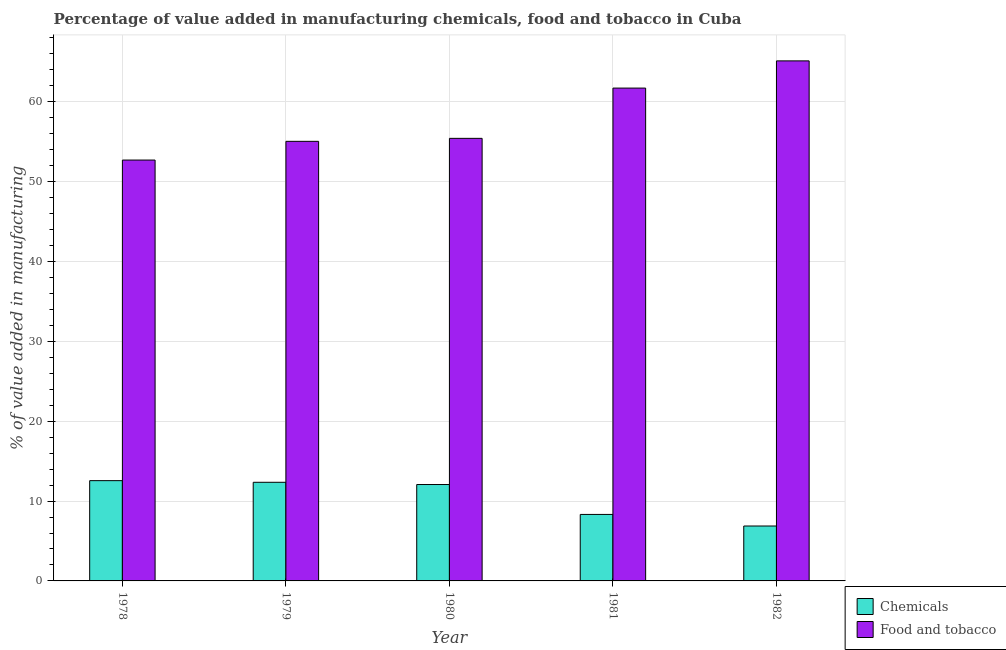How many groups of bars are there?
Keep it short and to the point. 5. Are the number of bars on each tick of the X-axis equal?
Your response must be concise. Yes. In how many cases, is the number of bars for a given year not equal to the number of legend labels?
Make the answer very short. 0. What is the value added by manufacturing food and tobacco in 1979?
Ensure brevity in your answer.  55.05. Across all years, what is the maximum value added by  manufacturing chemicals?
Give a very brief answer. 12.56. Across all years, what is the minimum value added by manufacturing food and tobacco?
Make the answer very short. 52.71. In which year was the value added by  manufacturing chemicals maximum?
Offer a terse response. 1978. In which year was the value added by  manufacturing chemicals minimum?
Give a very brief answer. 1982. What is the total value added by manufacturing food and tobacco in the graph?
Make the answer very short. 290.03. What is the difference between the value added by  manufacturing chemicals in 1980 and that in 1981?
Provide a succinct answer. 3.75. What is the difference between the value added by manufacturing food and tobacco in 1982 and the value added by  manufacturing chemicals in 1980?
Ensure brevity in your answer.  9.7. What is the average value added by manufacturing food and tobacco per year?
Provide a short and direct response. 58.01. In how many years, is the value added by  manufacturing chemicals greater than 8 %?
Give a very brief answer. 4. What is the ratio of the value added by manufacturing food and tobacco in 1978 to that in 1980?
Provide a short and direct response. 0.95. What is the difference between the highest and the second highest value added by manufacturing food and tobacco?
Your response must be concise. 3.41. What is the difference between the highest and the lowest value added by  manufacturing chemicals?
Your answer should be very brief. 5.68. In how many years, is the value added by  manufacturing chemicals greater than the average value added by  manufacturing chemicals taken over all years?
Provide a short and direct response. 3. Is the sum of the value added by  manufacturing chemicals in 1981 and 1982 greater than the maximum value added by manufacturing food and tobacco across all years?
Offer a very short reply. Yes. What does the 1st bar from the left in 1981 represents?
Make the answer very short. Chemicals. What does the 2nd bar from the right in 1978 represents?
Keep it short and to the point. Chemicals. Are all the bars in the graph horizontal?
Ensure brevity in your answer.  No. How many years are there in the graph?
Offer a very short reply. 5. What is the difference between two consecutive major ticks on the Y-axis?
Offer a terse response. 10. Are the values on the major ticks of Y-axis written in scientific E-notation?
Provide a succinct answer. No. Does the graph contain any zero values?
Provide a succinct answer. No. Does the graph contain grids?
Ensure brevity in your answer.  Yes. Where does the legend appear in the graph?
Provide a succinct answer. Bottom right. How are the legend labels stacked?
Keep it short and to the point. Vertical. What is the title of the graph?
Make the answer very short. Percentage of value added in manufacturing chemicals, food and tobacco in Cuba. What is the label or title of the X-axis?
Give a very brief answer. Year. What is the label or title of the Y-axis?
Your answer should be compact. % of value added in manufacturing. What is the % of value added in manufacturing in Chemicals in 1978?
Provide a short and direct response. 12.56. What is the % of value added in manufacturing of Food and tobacco in 1978?
Offer a very short reply. 52.71. What is the % of value added in manufacturing in Chemicals in 1979?
Provide a succinct answer. 12.35. What is the % of value added in manufacturing of Food and tobacco in 1979?
Offer a terse response. 55.05. What is the % of value added in manufacturing in Chemicals in 1980?
Keep it short and to the point. 12.07. What is the % of value added in manufacturing in Food and tobacco in 1980?
Make the answer very short. 55.42. What is the % of value added in manufacturing in Chemicals in 1981?
Your response must be concise. 8.33. What is the % of value added in manufacturing in Food and tobacco in 1981?
Offer a terse response. 61.72. What is the % of value added in manufacturing in Chemicals in 1982?
Provide a short and direct response. 6.88. What is the % of value added in manufacturing in Food and tobacco in 1982?
Your response must be concise. 65.13. Across all years, what is the maximum % of value added in manufacturing of Chemicals?
Your answer should be very brief. 12.56. Across all years, what is the maximum % of value added in manufacturing of Food and tobacco?
Make the answer very short. 65.13. Across all years, what is the minimum % of value added in manufacturing in Chemicals?
Ensure brevity in your answer.  6.88. Across all years, what is the minimum % of value added in manufacturing in Food and tobacco?
Make the answer very short. 52.71. What is the total % of value added in manufacturing of Chemicals in the graph?
Your answer should be very brief. 52.18. What is the total % of value added in manufacturing in Food and tobacco in the graph?
Offer a very short reply. 290.03. What is the difference between the % of value added in manufacturing of Chemicals in 1978 and that in 1979?
Your answer should be very brief. 0.21. What is the difference between the % of value added in manufacturing in Food and tobacco in 1978 and that in 1979?
Offer a very short reply. -2.34. What is the difference between the % of value added in manufacturing of Chemicals in 1978 and that in 1980?
Your answer should be very brief. 0.49. What is the difference between the % of value added in manufacturing of Food and tobacco in 1978 and that in 1980?
Offer a terse response. -2.72. What is the difference between the % of value added in manufacturing in Chemicals in 1978 and that in 1981?
Offer a terse response. 4.23. What is the difference between the % of value added in manufacturing of Food and tobacco in 1978 and that in 1981?
Keep it short and to the point. -9.01. What is the difference between the % of value added in manufacturing of Chemicals in 1978 and that in 1982?
Provide a short and direct response. 5.68. What is the difference between the % of value added in manufacturing of Food and tobacco in 1978 and that in 1982?
Offer a terse response. -12.42. What is the difference between the % of value added in manufacturing in Chemicals in 1979 and that in 1980?
Your answer should be very brief. 0.28. What is the difference between the % of value added in manufacturing of Food and tobacco in 1979 and that in 1980?
Offer a very short reply. -0.37. What is the difference between the % of value added in manufacturing of Chemicals in 1979 and that in 1981?
Offer a very short reply. 4.03. What is the difference between the % of value added in manufacturing in Food and tobacco in 1979 and that in 1981?
Make the answer very short. -6.67. What is the difference between the % of value added in manufacturing in Chemicals in 1979 and that in 1982?
Offer a very short reply. 5.47. What is the difference between the % of value added in manufacturing in Food and tobacco in 1979 and that in 1982?
Your response must be concise. -10.08. What is the difference between the % of value added in manufacturing of Chemicals in 1980 and that in 1981?
Give a very brief answer. 3.75. What is the difference between the % of value added in manufacturing in Food and tobacco in 1980 and that in 1981?
Your answer should be compact. -6.3. What is the difference between the % of value added in manufacturing of Chemicals in 1980 and that in 1982?
Make the answer very short. 5.19. What is the difference between the % of value added in manufacturing in Food and tobacco in 1980 and that in 1982?
Keep it short and to the point. -9.7. What is the difference between the % of value added in manufacturing in Chemicals in 1981 and that in 1982?
Provide a short and direct response. 1.45. What is the difference between the % of value added in manufacturing in Food and tobacco in 1981 and that in 1982?
Your response must be concise. -3.41. What is the difference between the % of value added in manufacturing in Chemicals in 1978 and the % of value added in manufacturing in Food and tobacco in 1979?
Give a very brief answer. -42.49. What is the difference between the % of value added in manufacturing in Chemicals in 1978 and the % of value added in manufacturing in Food and tobacco in 1980?
Your answer should be compact. -42.87. What is the difference between the % of value added in manufacturing in Chemicals in 1978 and the % of value added in manufacturing in Food and tobacco in 1981?
Ensure brevity in your answer.  -49.16. What is the difference between the % of value added in manufacturing in Chemicals in 1978 and the % of value added in manufacturing in Food and tobacco in 1982?
Your response must be concise. -52.57. What is the difference between the % of value added in manufacturing in Chemicals in 1979 and the % of value added in manufacturing in Food and tobacco in 1980?
Your response must be concise. -43.07. What is the difference between the % of value added in manufacturing in Chemicals in 1979 and the % of value added in manufacturing in Food and tobacco in 1981?
Keep it short and to the point. -49.37. What is the difference between the % of value added in manufacturing of Chemicals in 1979 and the % of value added in manufacturing of Food and tobacco in 1982?
Provide a short and direct response. -52.78. What is the difference between the % of value added in manufacturing in Chemicals in 1980 and the % of value added in manufacturing in Food and tobacco in 1981?
Give a very brief answer. -49.65. What is the difference between the % of value added in manufacturing of Chemicals in 1980 and the % of value added in manufacturing of Food and tobacco in 1982?
Your answer should be very brief. -53.06. What is the difference between the % of value added in manufacturing of Chemicals in 1981 and the % of value added in manufacturing of Food and tobacco in 1982?
Your response must be concise. -56.8. What is the average % of value added in manufacturing in Chemicals per year?
Provide a succinct answer. 10.44. What is the average % of value added in manufacturing of Food and tobacco per year?
Ensure brevity in your answer.  58.01. In the year 1978, what is the difference between the % of value added in manufacturing in Chemicals and % of value added in manufacturing in Food and tobacco?
Your answer should be compact. -40.15. In the year 1979, what is the difference between the % of value added in manufacturing of Chemicals and % of value added in manufacturing of Food and tobacco?
Your answer should be compact. -42.7. In the year 1980, what is the difference between the % of value added in manufacturing in Chemicals and % of value added in manufacturing in Food and tobacco?
Keep it short and to the point. -43.35. In the year 1981, what is the difference between the % of value added in manufacturing in Chemicals and % of value added in manufacturing in Food and tobacco?
Your answer should be compact. -53.39. In the year 1982, what is the difference between the % of value added in manufacturing in Chemicals and % of value added in manufacturing in Food and tobacco?
Provide a short and direct response. -58.25. What is the ratio of the % of value added in manufacturing in Chemicals in 1978 to that in 1979?
Your response must be concise. 1.02. What is the ratio of the % of value added in manufacturing of Food and tobacco in 1978 to that in 1979?
Offer a terse response. 0.96. What is the ratio of the % of value added in manufacturing in Chemicals in 1978 to that in 1980?
Provide a short and direct response. 1.04. What is the ratio of the % of value added in manufacturing in Food and tobacco in 1978 to that in 1980?
Ensure brevity in your answer.  0.95. What is the ratio of the % of value added in manufacturing in Chemicals in 1978 to that in 1981?
Your answer should be very brief. 1.51. What is the ratio of the % of value added in manufacturing of Food and tobacco in 1978 to that in 1981?
Offer a terse response. 0.85. What is the ratio of the % of value added in manufacturing in Chemicals in 1978 to that in 1982?
Provide a short and direct response. 1.83. What is the ratio of the % of value added in manufacturing of Food and tobacco in 1978 to that in 1982?
Your response must be concise. 0.81. What is the ratio of the % of value added in manufacturing of Chemicals in 1979 to that in 1980?
Your answer should be very brief. 1.02. What is the ratio of the % of value added in manufacturing in Chemicals in 1979 to that in 1981?
Your answer should be very brief. 1.48. What is the ratio of the % of value added in manufacturing in Food and tobacco in 1979 to that in 1981?
Your response must be concise. 0.89. What is the ratio of the % of value added in manufacturing in Chemicals in 1979 to that in 1982?
Provide a short and direct response. 1.8. What is the ratio of the % of value added in manufacturing of Food and tobacco in 1979 to that in 1982?
Make the answer very short. 0.85. What is the ratio of the % of value added in manufacturing in Chemicals in 1980 to that in 1981?
Keep it short and to the point. 1.45. What is the ratio of the % of value added in manufacturing in Food and tobacco in 1980 to that in 1981?
Offer a terse response. 0.9. What is the ratio of the % of value added in manufacturing in Chemicals in 1980 to that in 1982?
Your answer should be very brief. 1.76. What is the ratio of the % of value added in manufacturing of Food and tobacco in 1980 to that in 1982?
Offer a terse response. 0.85. What is the ratio of the % of value added in manufacturing in Chemicals in 1981 to that in 1982?
Your response must be concise. 1.21. What is the ratio of the % of value added in manufacturing in Food and tobacco in 1981 to that in 1982?
Your answer should be compact. 0.95. What is the difference between the highest and the second highest % of value added in manufacturing in Chemicals?
Provide a succinct answer. 0.21. What is the difference between the highest and the second highest % of value added in manufacturing of Food and tobacco?
Your answer should be very brief. 3.41. What is the difference between the highest and the lowest % of value added in manufacturing in Chemicals?
Keep it short and to the point. 5.68. What is the difference between the highest and the lowest % of value added in manufacturing in Food and tobacco?
Give a very brief answer. 12.42. 